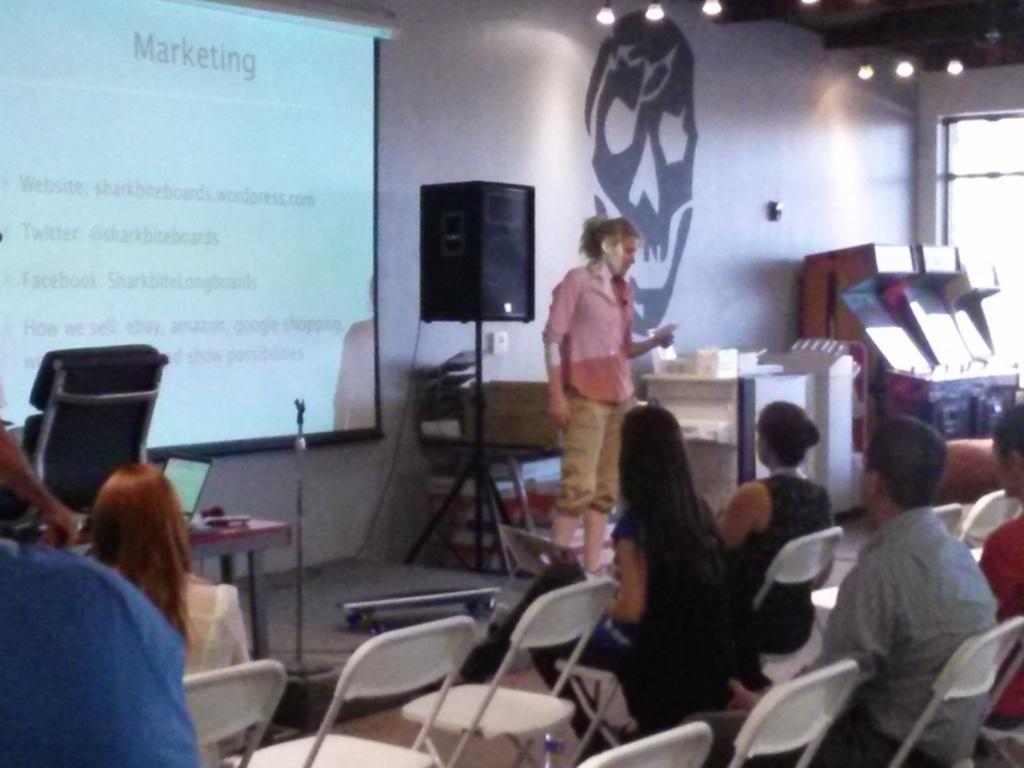Please provide a concise description of this image. In this image I can see number of people where in the front I can see few are sitting and in the background one is standing. In the background I can also see a chair, a speaker, a projector screen, few other stuffs and on the wall I can see a black colour sticker. On the top right side of this image I can see few lights and in the front I can see few empty chairs. 